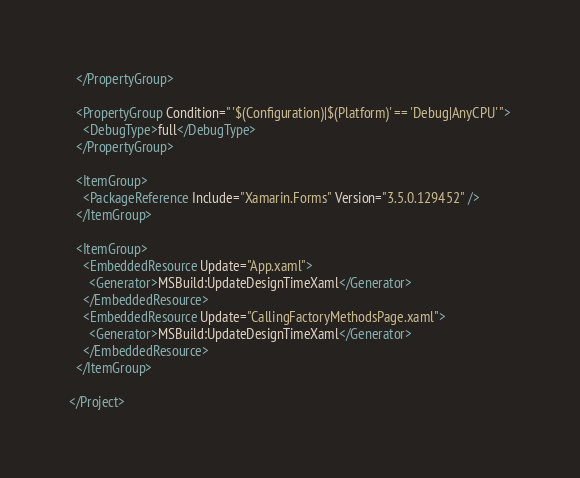<code> <loc_0><loc_0><loc_500><loc_500><_XML_>  </PropertyGroup>

  <PropertyGroup Condition=" '$(Configuration)|$(Platform)' == 'Debug|AnyCPU' ">
    <DebugType>full</DebugType>
  </PropertyGroup>

  <ItemGroup>
    <PackageReference Include="Xamarin.Forms" Version="3.5.0.129452" />
  </ItemGroup>

  <ItemGroup>
    <EmbeddedResource Update="App.xaml">
      <Generator>MSBuild:UpdateDesignTimeXaml</Generator>
    </EmbeddedResource>
    <EmbeddedResource Update="CallingFactoryMethodsPage.xaml">
      <Generator>MSBuild:UpdateDesignTimeXaml</Generator>
    </EmbeddedResource>
  </ItemGroup>

</Project></code> 